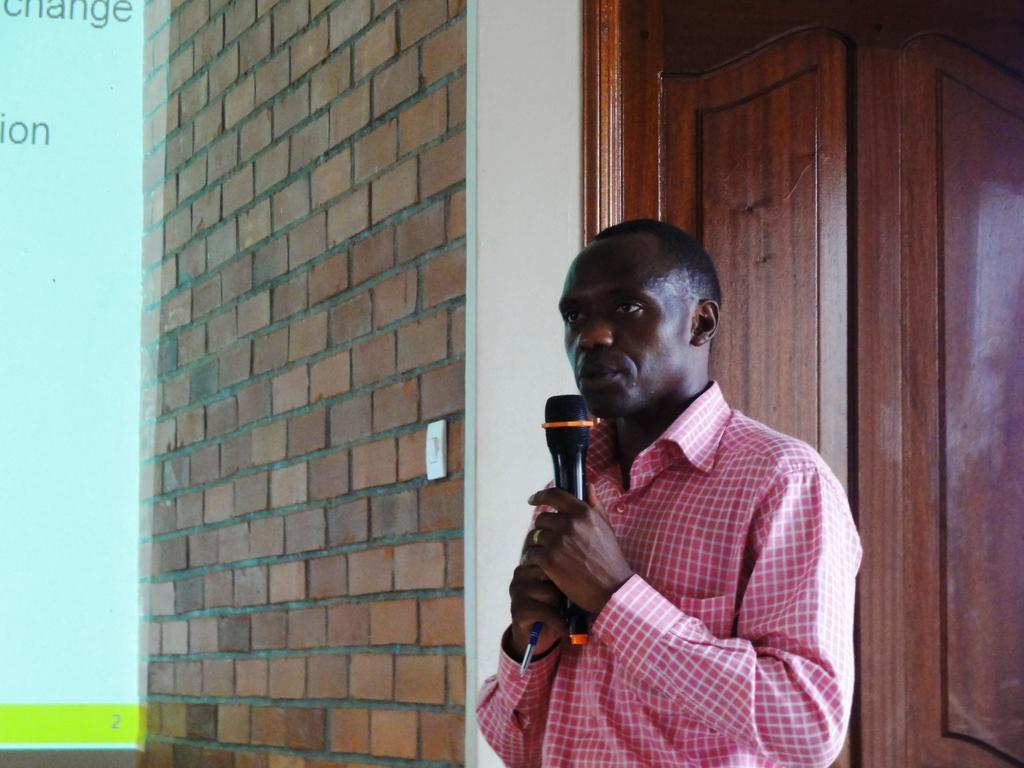Who is the main subject in the image? There is a man in the image. What is the man holding in his hand? The man is holding a microphone in his hand. How many apples can be seen in the image? There are no apples present in the image. What sense is the man using to communicate with the microphone? The question is not helpful, as it assumes the man is using the microphone to communicate, which is not mentioned in the facts. The image only shows a man holding a microphone, and we cannot determine his intentions or actions based on the provided information. 